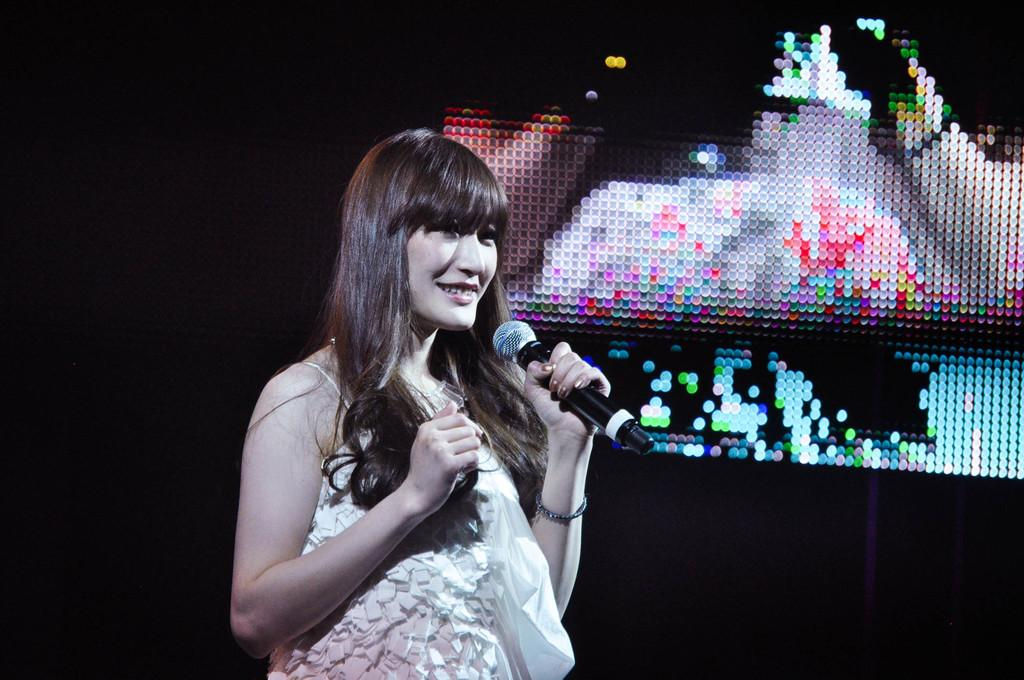Who is the main subject in the image? There is a woman in the image. What is the woman doing in the image? The woman is standing on a stage and smiling. What is the woman holding in her hand? The woman is holding a microphone in her hand. What can be seen in the background of the image? There is a screen in the background of the image. What type of science experiment is being conducted on the stage in the image? There is no science experiment being conducted in the image; the woman is holding a microphone and smiling. 